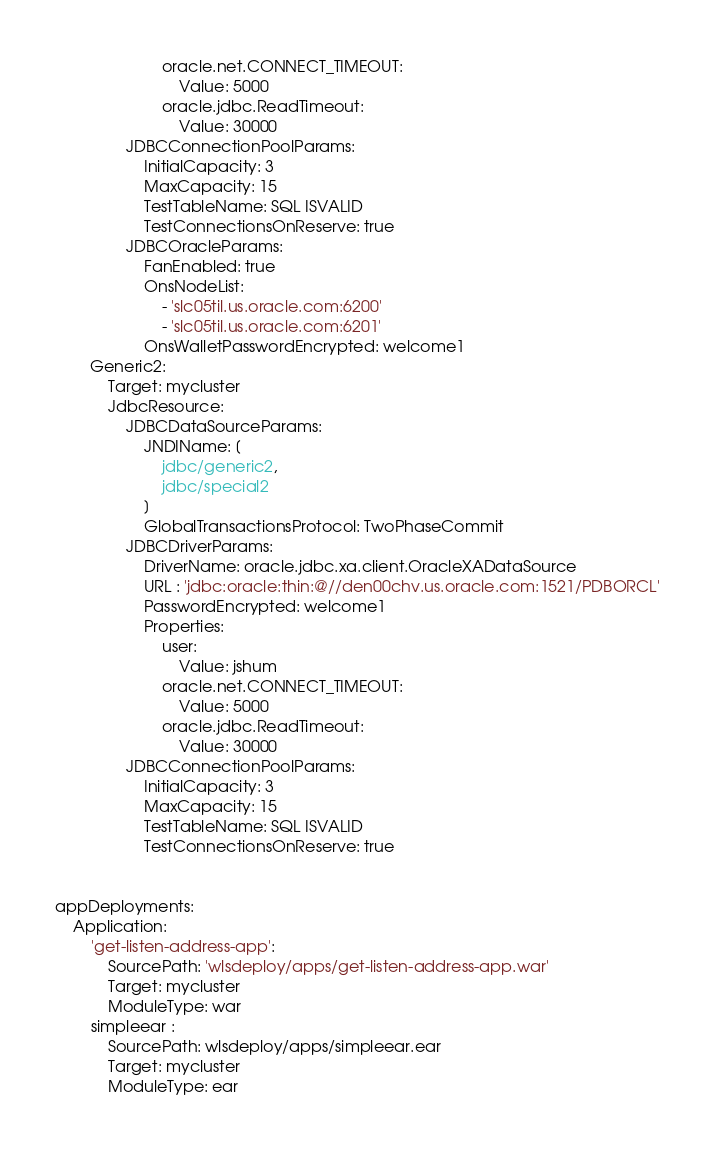Convert code to text. <code><loc_0><loc_0><loc_500><loc_500><_YAML_>                        oracle.net.CONNECT_TIMEOUT:
                            Value: 5000
                        oracle.jdbc.ReadTimeout:
                            Value: 30000
                JDBCConnectionPoolParams:
                    InitialCapacity: 3
                    MaxCapacity: 15
                    TestTableName: SQL ISVALID
                    TestConnectionsOnReserve: true
                JDBCOracleParams:
                    FanEnabled: true
                    OnsNodeList:
                        - 'slc05til.us.oracle.com:6200'
                        - 'slc05til.us.oracle.com:6201'
                    OnsWalletPasswordEncrypted: welcome1
        Generic2:
            Target: mycluster
            JdbcResource:
                JDBCDataSourceParams:
                    JNDIName: [
                        jdbc/generic2,
                        jdbc/special2
                    ]
                    GlobalTransactionsProtocol: TwoPhaseCommit
                JDBCDriverParams:
                    DriverName: oracle.jdbc.xa.client.OracleXADataSource
                    URL : 'jdbc:oracle:thin:@//den00chv.us.oracle.com:1521/PDBORCL'
                    PasswordEncrypted: welcome1
                    Properties:
                        user:
                            Value: jshum
                        oracle.net.CONNECT_TIMEOUT:
                            Value: 5000
                        oracle.jdbc.ReadTimeout:
                            Value: 30000
                JDBCConnectionPoolParams:
                    InitialCapacity: 3
                    MaxCapacity: 15
                    TestTableName: SQL ISVALID
                    TestConnectionsOnReserve: true


appDeployments:
    Application:
        'get-listen-address-app':
            SourcePath: 'wlsdeploy/apps/get-listen-address-app.war'
            Target: mycluster
            ModuleType: war
        simpleear :
            SourcePath: wlsdeploy/apps/simpleear.ear
            Target: mycluster
            ModuleType: ear
</code> 